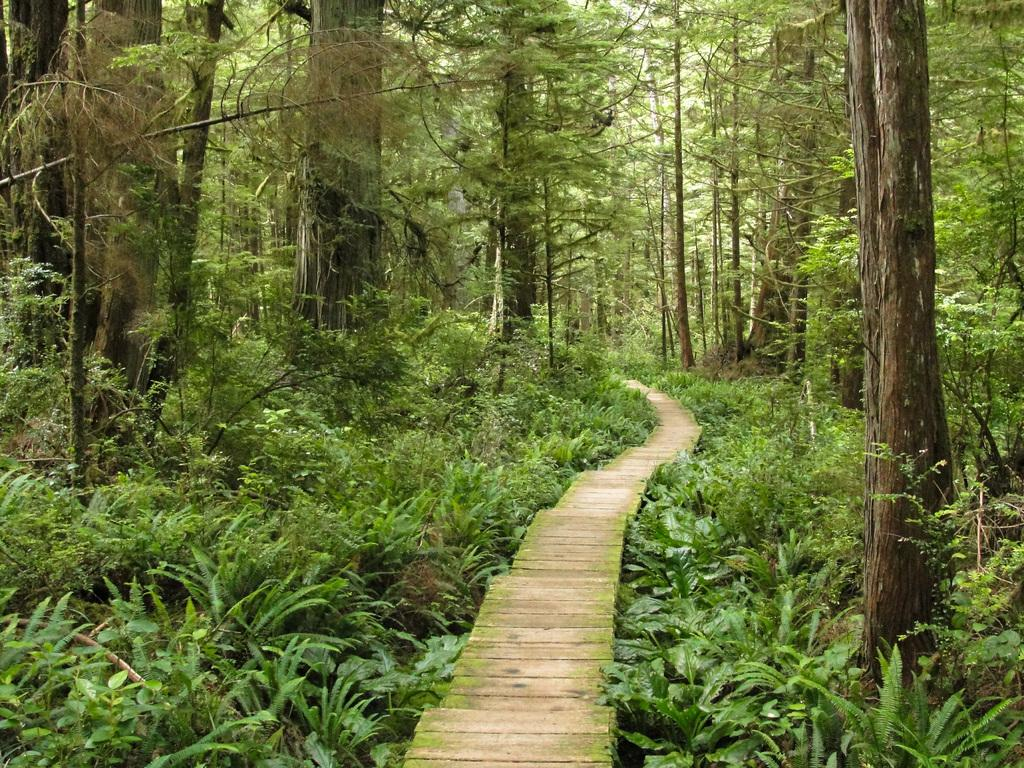What type of vegetation is present in the image? There are green color trees and small plants in the image. What material is the path made of in the image? The path in the image is made of wood. What type of memory is stored in the wooden path in the image? There is no mention of memory in the image, as it features trees, plants, and a wooden path. 